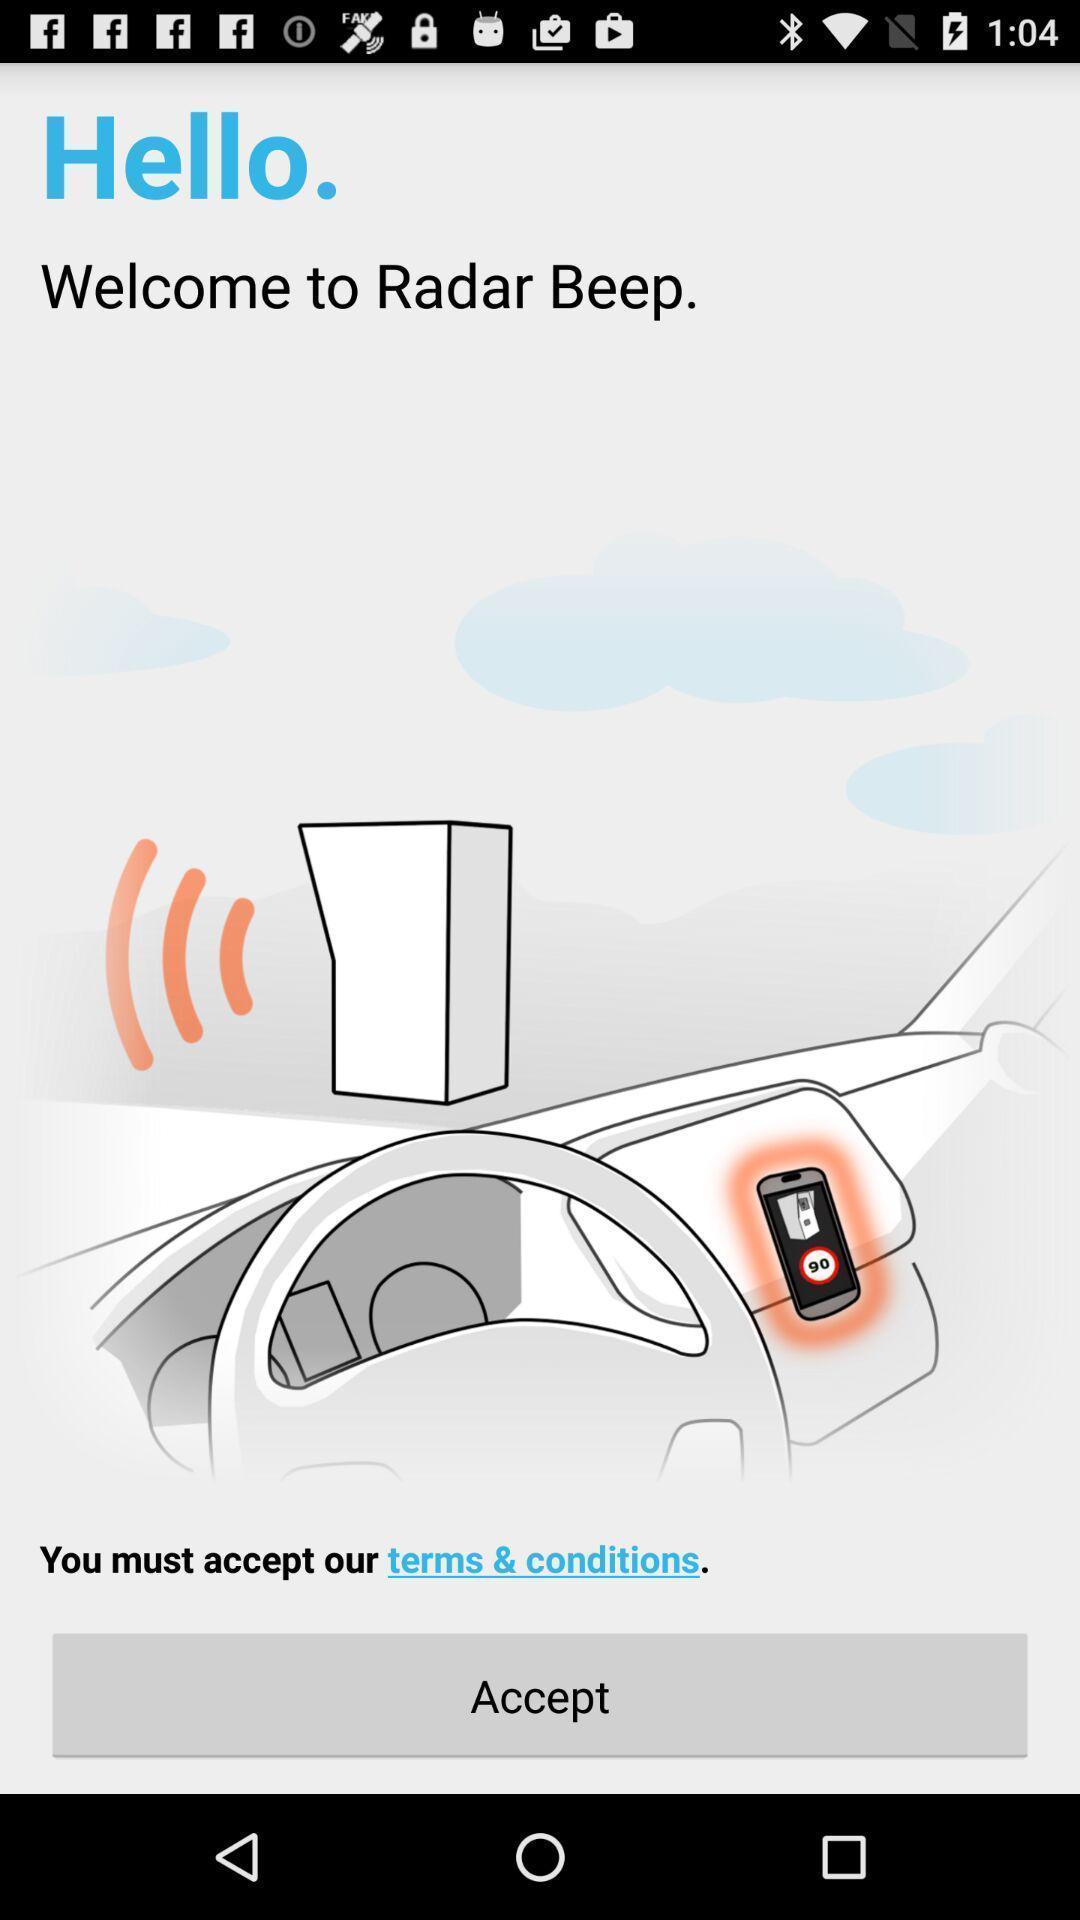Summarize the information in this screenshot. Welcome page of hello app. 